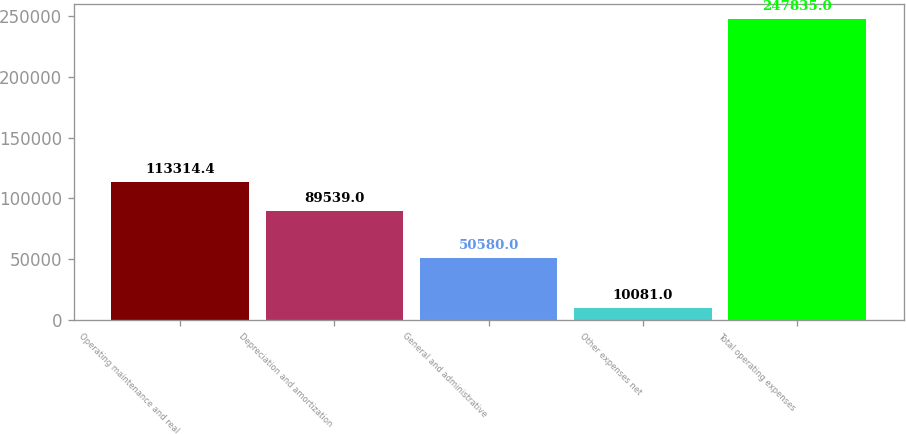<chart> <loc_0><loc_0><loc_500><loc_500><bar_chart><fcel>Operating maintenance and real<fcel>Depreciation and amortization<fcel>General and administrative<fcel>Other expenses net<fcel>Total operating expenses<nl><fcel>113314<fcel>89539<fcel>50580<fcel>10081<fcel>247835<nl></chart> 